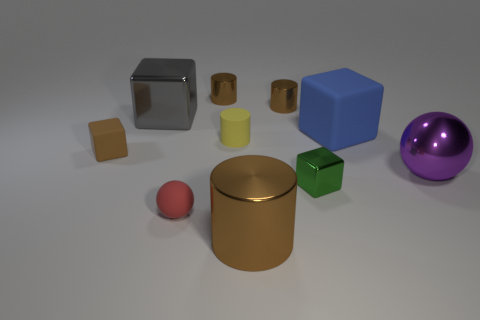Subtract all brown cylinders. How many cylinders are left? 1 Subtract all green shiny cubes. How many cubes are left? 3 Subtract 1 green cubes. How many objects are left? 9 Subtract all blocks. How many objects are left? 6 Subtract 2 spheres. How many spheres are left? 0 Subtract all purple balls. Subtract all purple cubes. How many balls are left? 1 Subtract all brown cylinders. How many red cubes are left? 0 Subtract all red rubber spheres. Subtract all tiny green shiny cubes. How many objects are left? 8 Add 8 big blue matte cubes. How many big blue matte cubes are left? 9 Add 2 tiny gray shiny blocks. How many tiny gray shiny blocks exist? 2 